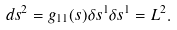Convert formula to latex. <formula><loc_0><loc_0><loc_500><loc_500>d s ^ { 2 } = g _ { 1 1 } ( s ) \delta s ^ { 1 } \delta s ^ { 1 } = L ^ { 2 } .</formula> 